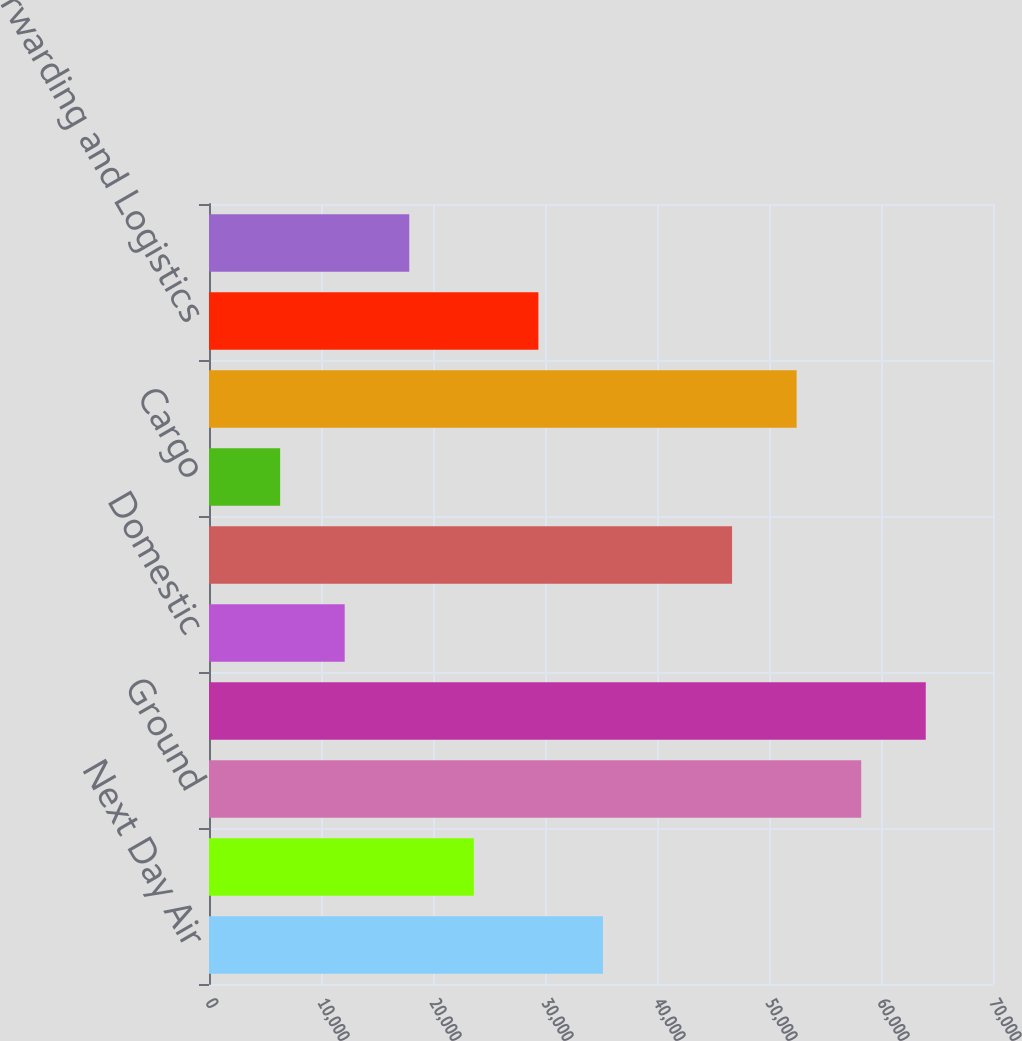Convert chart to OTSL. <chart><loc_0><loc_0><loc_500><loc_500><bar_chart><fcel>Next Day Air<fcel>Deferred<fcel>Ground<fcel>Total US Domestic Package<fcel>Domestic<fcel>Export<fcel>Cargo<fcel>Total International Package<fcel>Forwarding and Logistics<fcel>Freight<nl><fcel>35174<fcel>23645<fcel>58232<fcel>63996.5<fcel>12116<fcel>46703<fcel>6351.5<fcel>52467.5<fcel>29409.5<fcel>17880.5<nl></chart> 